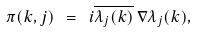Convert formula to latex. <formula><loc_0><loc_0><loc_500><loc_500>\pi ( k , j ) \ = \ i \overline { \lambda _ { j } ( k ) } \, \nabla \lambda _ { j } ( k ) ,</formula> 